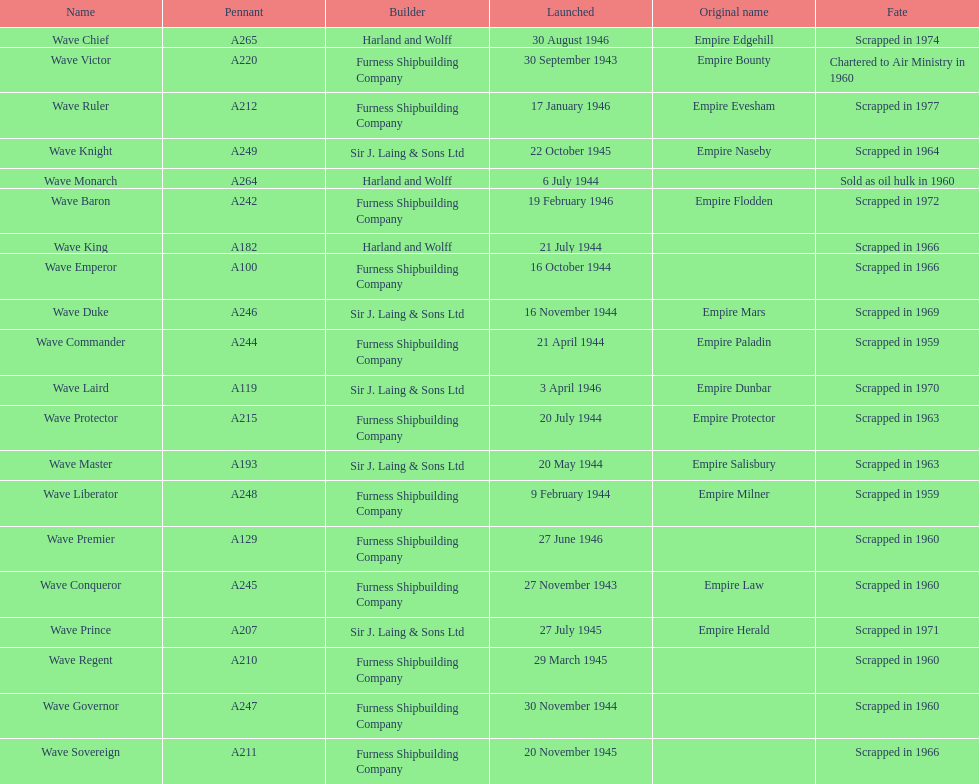How many ships were launched in the year 1944? 9. 